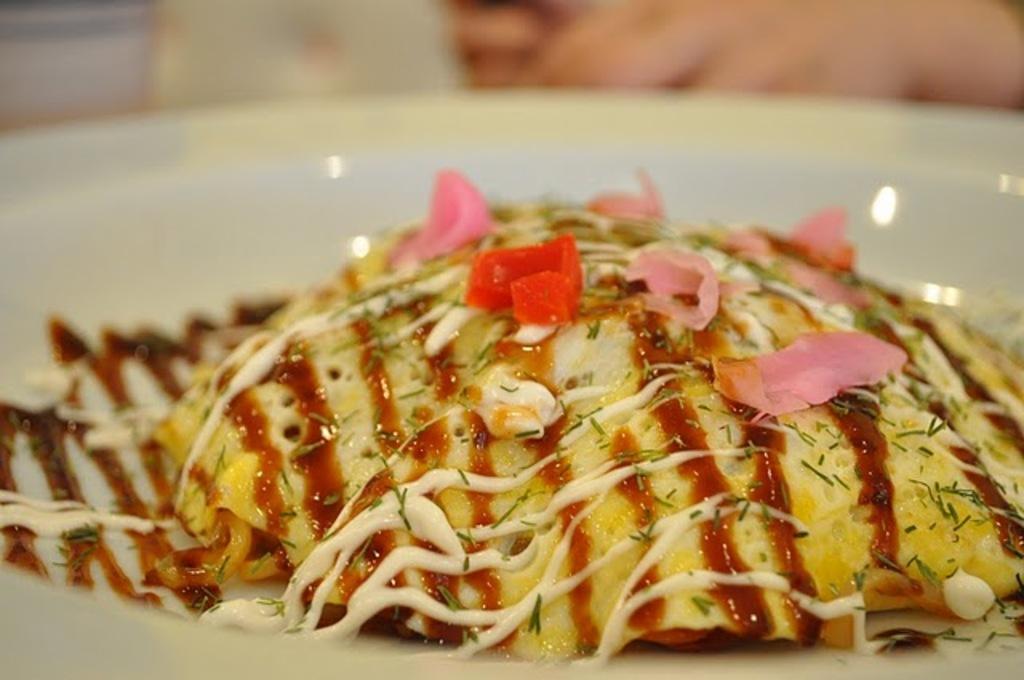In one or two sentences, can you explain what this image depicts? In this picture we can see food item on the white. Here we can see some grains. 